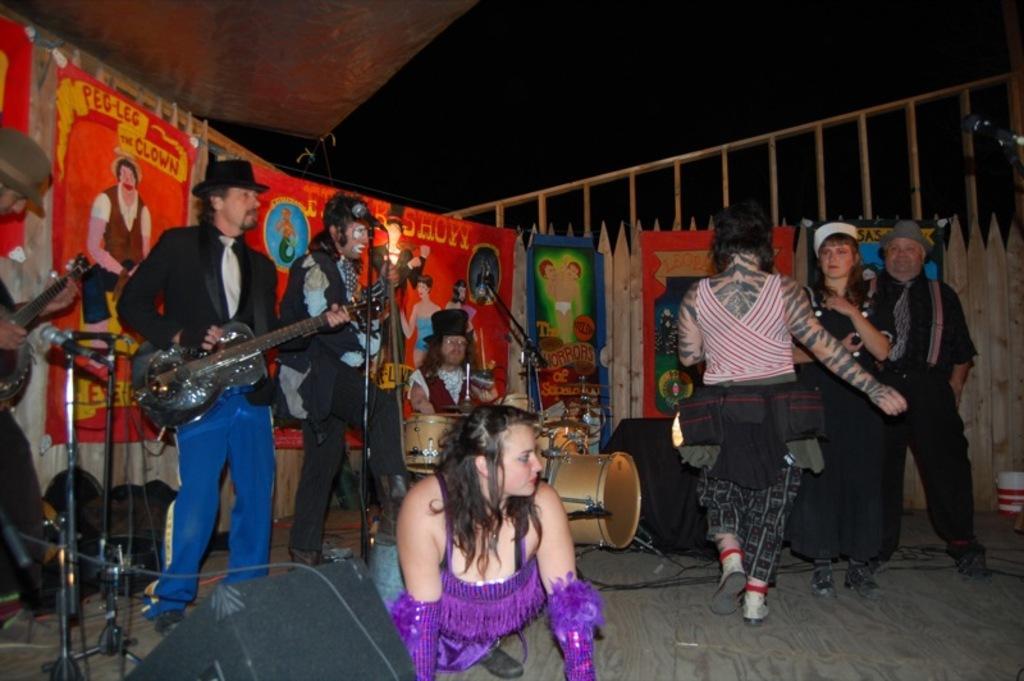Describe this image in one or two sentences. In this image there are group of persons who are playing musical instruments and at the bottom left of the image there is a sound box and at the top of the image there is a fencing. 